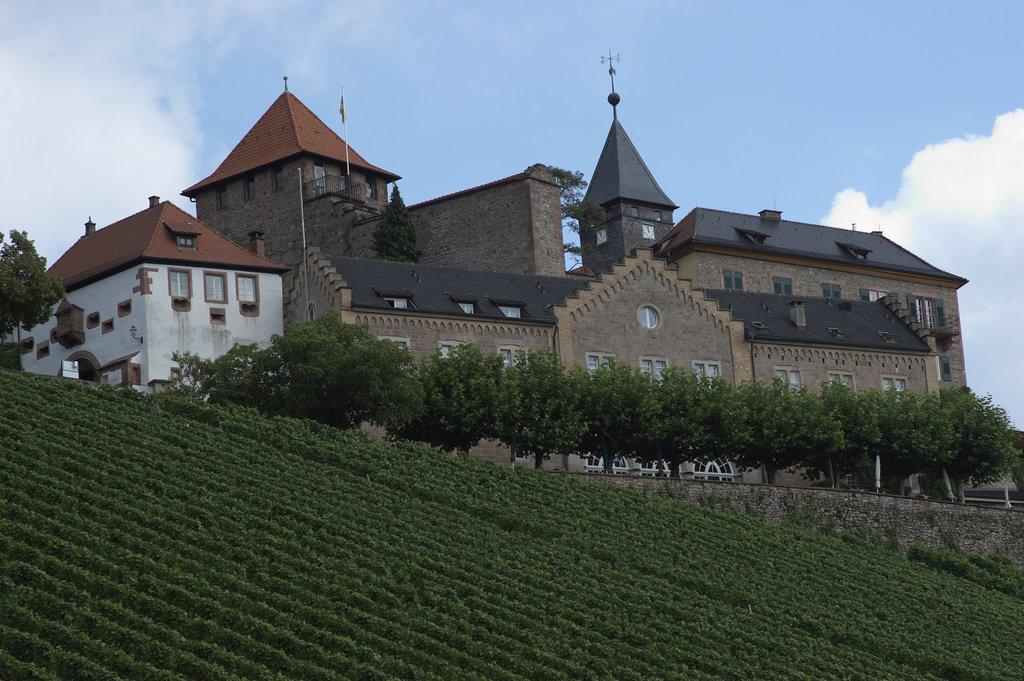What type of vegetation is present in the image? There are green color plants and trees in the image. What structure can be seen in the image? There is a building in the image. What color is the sky in the image? The sky is blue in color. Can you see the reflection of the chin in the lake in the image? There is no lake or reflection of a chin present in the image. 